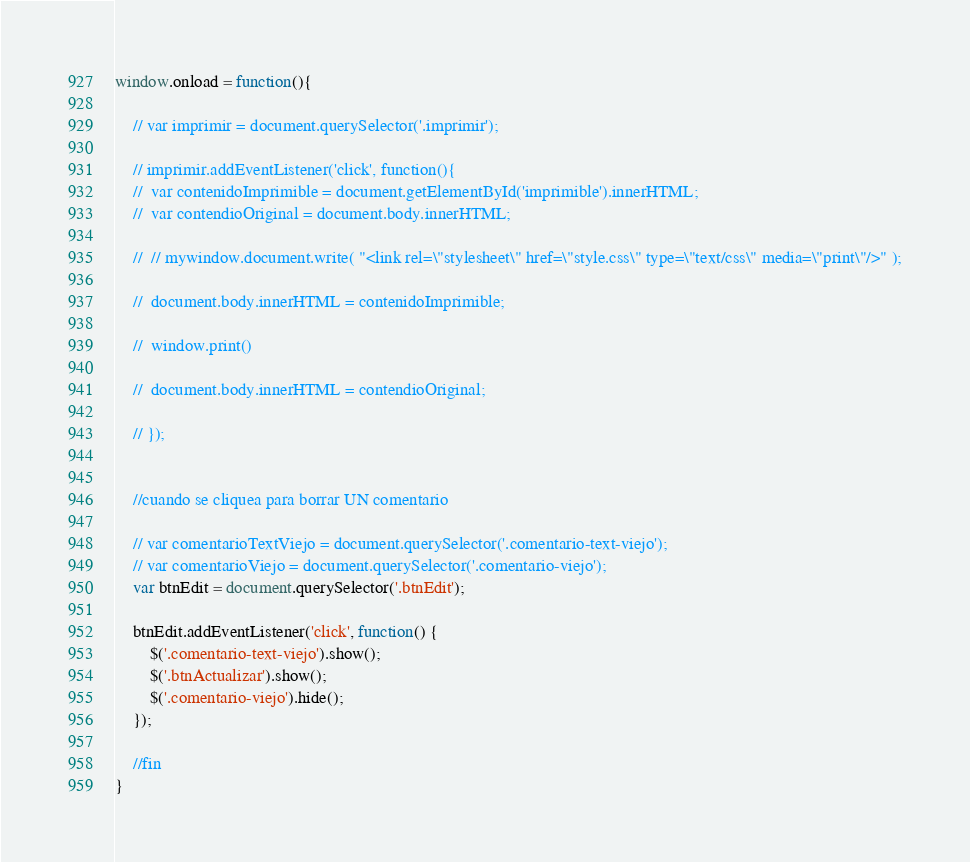<code> <loc_0><loc_0><loc_500><loc_500><_JavaScript_>window.onload = function(){

	// var imprimir = document.querySelector('.imprimir');

	// imprimir.addEventListener('click', function(){
 	// 	var contenidoImprimible = document.getElementById('imprimible').innerHTML;
 	// 	var contendioOriginal = document.body.innerHTML;
 		
 	// 	// mywindow.document.write( "<link rel=\"stylesheet\" href=\"style.css\" type=\"text/css\" media=\"print\"/>" );
		
	// 	document.body.innerHTML = contenidoImprimible;

	// 	window.print()

 	// 	document.body.innerHTML = contendioOriginal;

	// });
	

	//cuando se cliquea para borrar UN comentario

	// var comentarioTextViejo = document.querySelector('.comentario-text-viejo');
	// var comentarioViejo = document.querySelector('.comentario-viejo');
	var btnEdit = document.querySelector('.btnEdit');
	
	btnEdit.addEventListener('click', function() {
		$('.comentario-text-viejo').show();
		$('.btnActualizar').show();
		$('.comentario-viejo').hide();
	});

	//fin
}</code> 